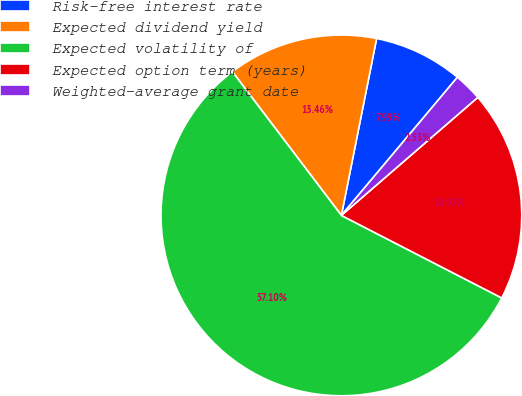Convert chart to OTSL. <chart><loc_0><loc_0><loc_500><loc_500><pie_chart><fcel>Risk-free interest rate<fcel>Expected dividend yield<fcel>Expected volatility of<fcel>Expected option term (years)<fcel>Weighted-average grant date<nl><fcel>7.99%<fcel>13.46%<fcel>57.11%<fcel>18.92%<fcel>2.53%<nl></chart> 